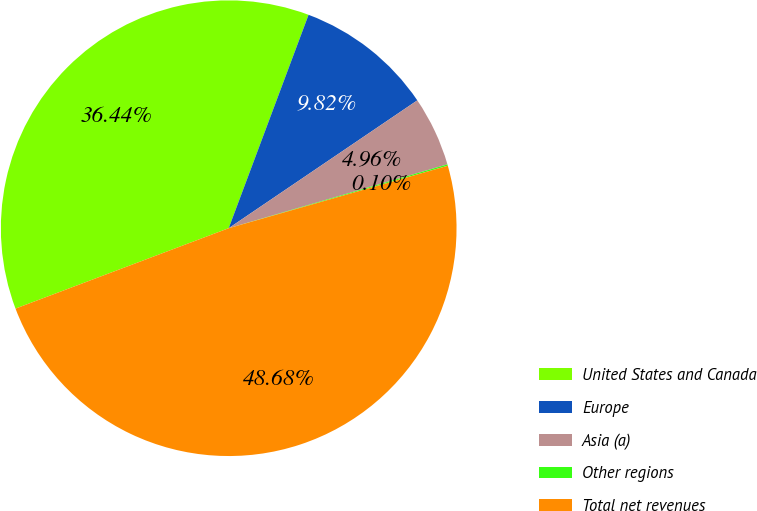Convert chart to OTSL. <chart><loc_0><loc_0><loc_500><loc_500><pie_chart><fcel>United States and Canada<fcel>Europe<fcel>Asia (a)<fcel>Other regions<fcel>Total net revenues<nl><fcel>36.44%<fcel>9.82%<fcel>4.96%<fcel>0.1%<fcel>48.68%<nl></chart> 